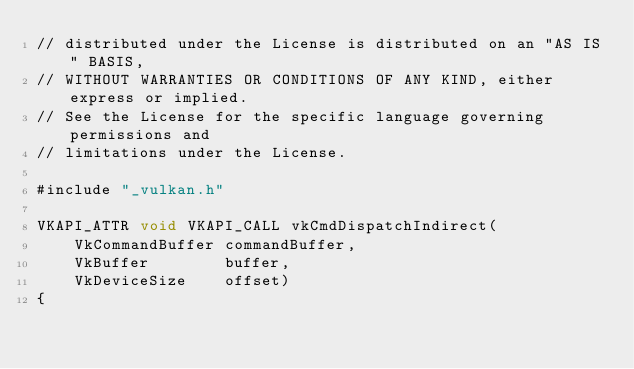<code> <loc_0><loc_0><loc_500><loc_500><_ObjectiveC_>// distributed under the License is distributed on an "AS IS" BASIS,
// WITHOUT WARRANTIES OR CONDITIONS OF ANY KIND, either express or implied.
// See the License for the specific language governing permissions and
// limitations under the License.

#include "_vulkan.h"

VKAPI_ATTR void VKAPI_CALL vkCmdDispatchIndirect(
    VkCommandBuffer commandBuffer,
    VkBuffer        buffer,
    VkDeviceSize    offset)
{</code> 